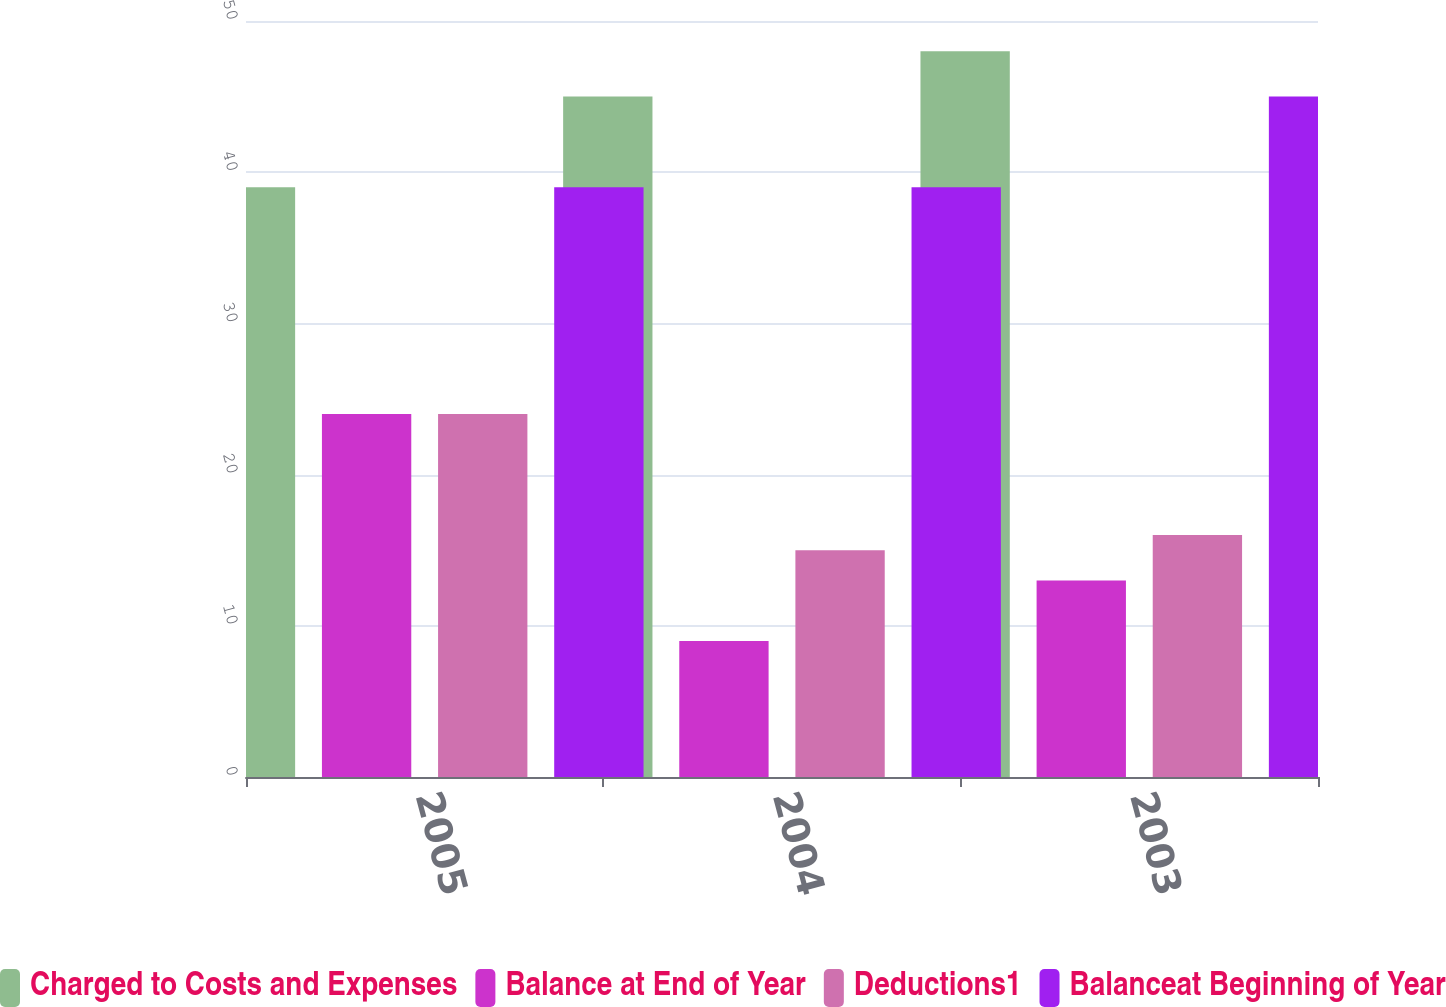Convert chart to OTSL. <chart><loc_0><loc_0><loc_500><loc_500><stacked_bar_chart><ecel><fcel>2005<fcel>2004<fcel>2003<nl><fcel>Charged to Costs and Expenses<fcel>39<fcel>45<fcel>48<nl><fcel>Balance at End of Year<fcel>24<fcel>9<fcel>13<nl><fcel>Deductions1<fcel>24<fcel>15<fcel>16<nl><fcel>Balanceat Beginning of Year<fcel>39<fcel>39<fcel>45<nl></chart> 